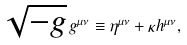Convert formula to latex. <formula><loc_0><loc_0><loc_500><loc_500>\sqrt { - g } \, g ^ { \mu \nu } \equiv \eta ^ { \mu \nu } + \kappa h ^ { \mu \nu } ,</formula> 